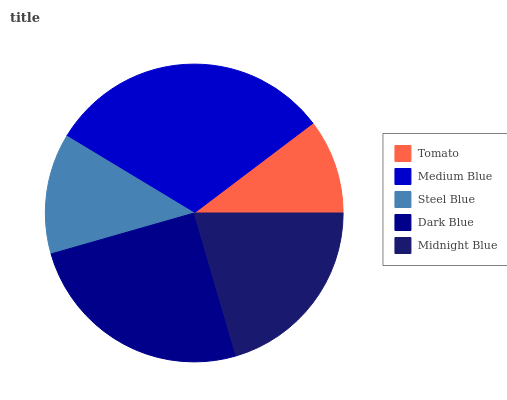Is Tomato the minimum?
Answer yes or no. Yes. Is Medium Blue the maximum?
Answer yes or no. Yes. Is Steel Blue the minimum?
Answer yes or no. No. Is Steel Blue the maximum?
Answer yes or no. No. Is Medium Blue greater than Steel Blue?
Answer yes or no. Yes. Is Steel Blue less than Medium Blue?
Answer yes or no. Yes. Is Steel Blue greater than Medium Blue?
Answer yes or no. No. Is Medium Blue less than Steel Blue?
Answer yes or no. No. Is Midnight Blue the high median?
Answer yes or no. Yes. Is Midnight Blue the low median?
Answer yes or no. Yes. Is Steel Blue the high median?
Answer yes or no. No. Is Medium Blue the low median?
Answer yes or no. No. 